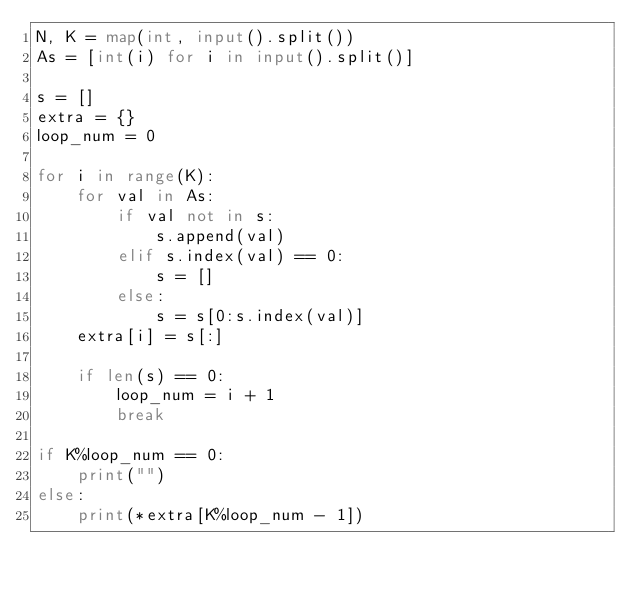Convert code to text. <code><loc_0><loc_0><loc_500><loc_500><_Python_>N, K = map(int, input().split())
As = [int(i) for i in input().split()]

s = []
extra = {}
loop_num = 0

for i in range(K):
    for val in As:
        if val not in s:
            s.append(val)
        elif s.index(val) == 0:
            s = []
        else:
            s = s[0:s.index(val)]
    extra[i] = s[:]

    if len(s) == 0:
        loop_num = i + 1
        break

if K%loop_num == 0:
    print("")
else:
    print(*extra[K%loop_num - 1])</code> 